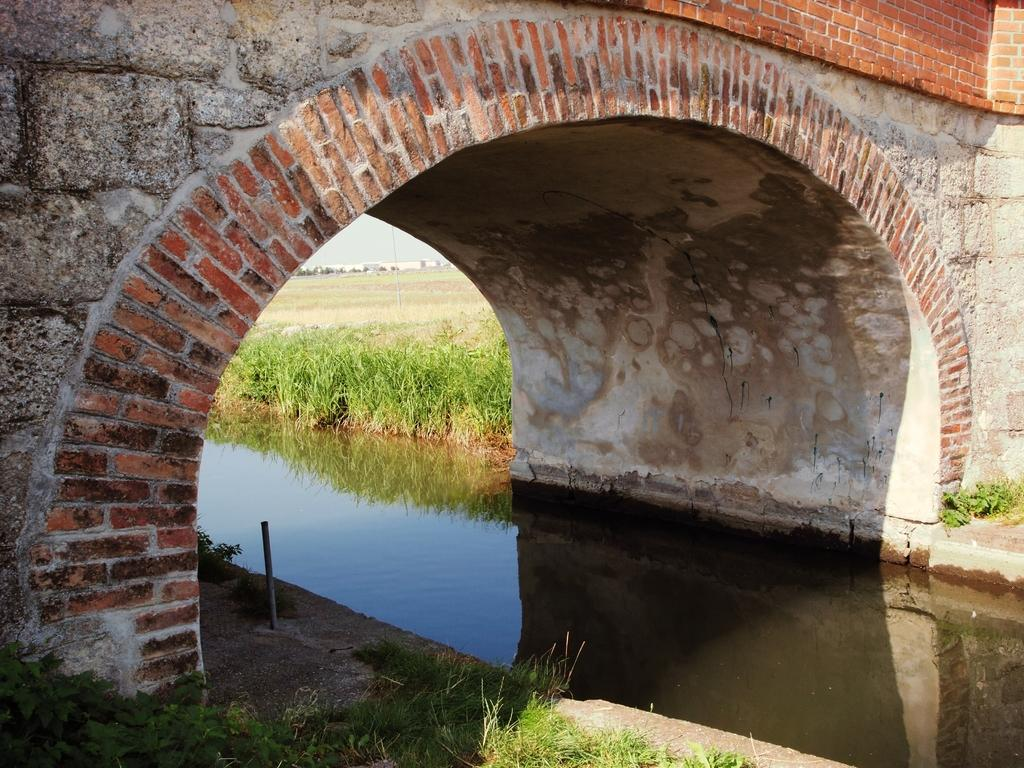What structure can be seen in the image? There is a bridge in the image. What natural element is visible in the image? There is water visible in the image. What object can be seen near the water? There is a rod in the image. What type of vegetation is present in the image? There is grass in the image. What can be seen in the distance in the image? There are buildings in the background of the image. What part of the natural environment is visible in the image? The sky is visible in the image. What type of stitch is used to create the linen pattern on the bridge in the image? There is no linen pattern or stitching present on the bridge in the image. How many cubs can be seen playing near the water in the image? There are no cubs present in the image. 